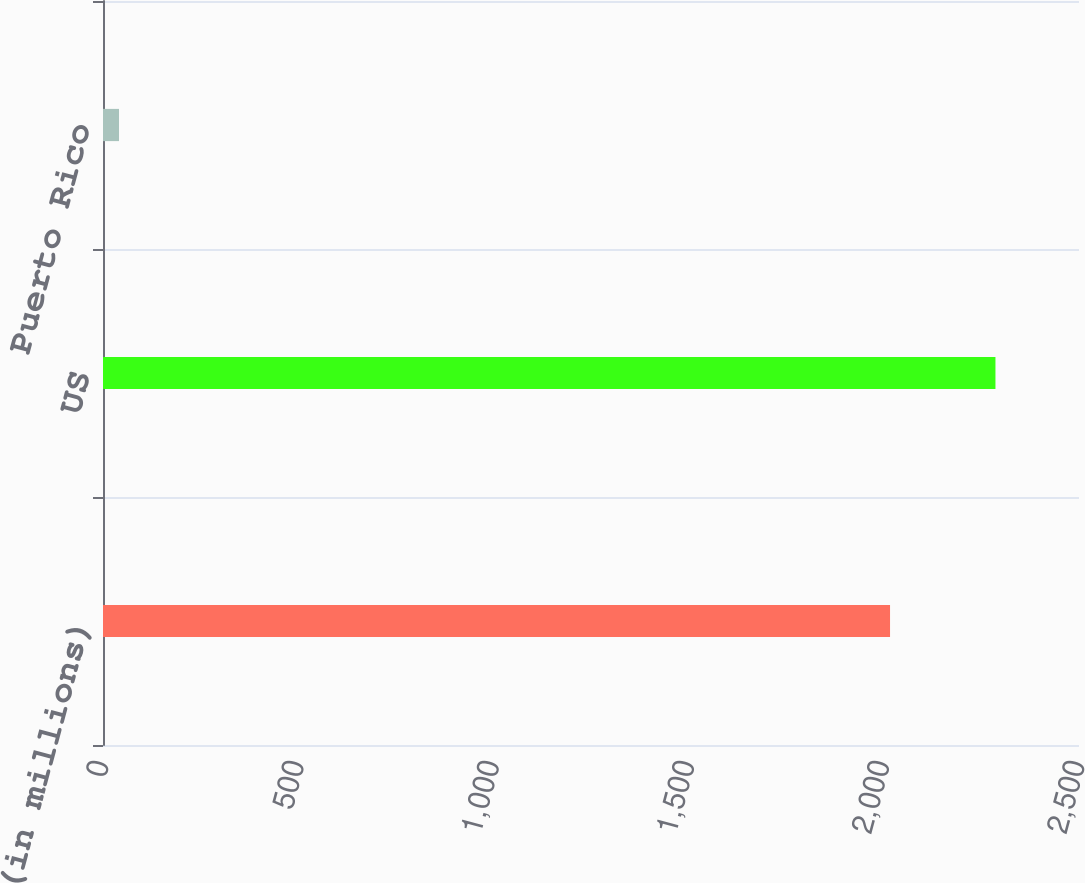Convert chart. <chart><loc_0><loc_0><loc_500><loc_500><bar_chart><fcel>(in millions)<fcel>US<fcel>Puerto Rico<nl><fcel>2016<fcel>2286<fcel>41<nl></chart> 